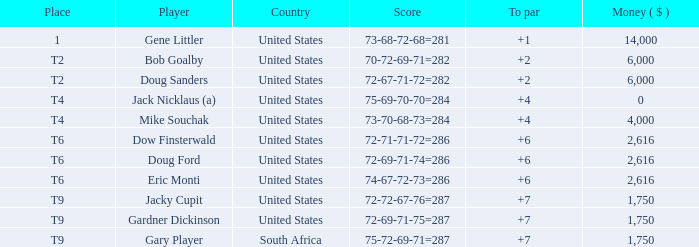What is the highest To Par, when Place is "1"? 1.0. 